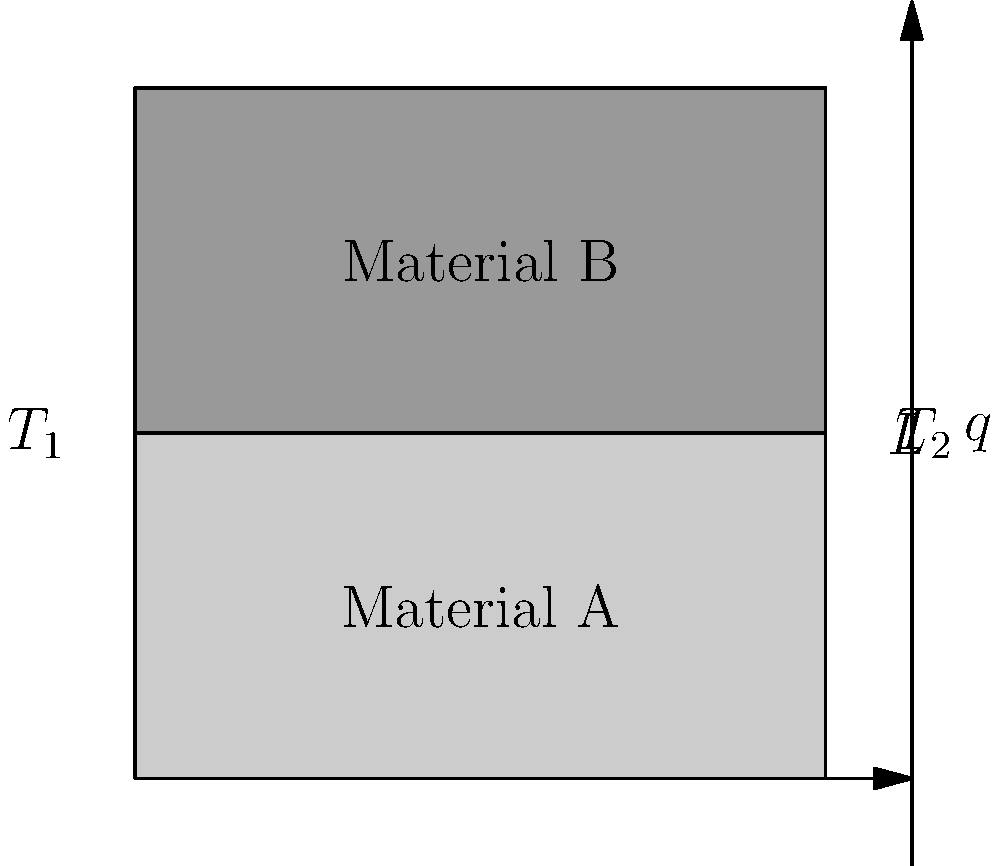A composite wall consists of two materials, A and B, each with a thickness of $L/2$. The thermal conductivities of materials A and B are $k_A$ and $k_B$, respectively. If the temperatures on the left and right sides of the wall are $T_1$ and $T_2$, and steady-state heat transfer occurs, what is the expression for the overall heat transfer rate per unit area ($q$) through the composite wall? To solve this problem, we'll follow these steps:

1) First, recall the general equation for heat transfer rate per unit area (heat flux) through a single material:

   $q = -k \frac{dT}{dx}$

   Where $k$ is the thermal conductivity, and $\frac{dT}{dx}$ is the temperature gradient.

2) For steady-state conduction through a plane wall, this becomes:

   $q = k \frac{T_1 - T_2}{L}$

3) In our composite wall, we have two materials in series. The total temperature difference $(T_1 - T_2)$ is divided across the two materials.

4) Let's call the temperature at the interface between A and B as $T_i$. Then:

   For material A: $q_A = k_A \frac{T_1 - T_i}{L/2}$
   For material B: $q_B = k_B \frac{T_i - T_2}{L/2}$

5) In steady-state, the heat flux through both materials must be equal:

   $q_A = q_B = q$

6) We can eliminate $T_i$ by adding the equations for $q_A$ and $q_B$:

   $q = k_A \frac{T_1 - T_i}{L/2} = k_B \frac{T_i - T_2}{L/2}$

7) Adding these equations:

   $q(\frac{L}{2k_A} + \frac{L}{2k_B}) = T_1 - T_2$

8) Solving for $q$:

   $q = \frac{T_1 - T_2}{\frac{L}{2k_A} + \frac{L}{2k_B}}$

9) This can be simplified to:

   $q = \frac{2(T_1 - T_2)}{L(\frac{1}{k_A} + \frac{1}{k_B})}$

This is the expression for the overall heat transfer rate per unit area through the composite wall.
Answer: $q = \frac{2(T_1 - T_2)}{L(\frac{1}{k_A} + \frac{1}{k_B})}$ 